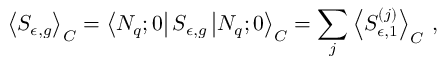Convert formula to latex. <formula><loc_0><loc_0><loc_500><loc_500>\left < S _ { \epsilon , g } \right > _ { C } = \left < N _ { q } ; 0 \right | S _ { \epsilon , g } \left | N _ { q } ; 0 \right > _ { C } = \sum _ { j } \left < S _ { \epsilon , 1 } ^ { ( j ) } \right > _ { C } \, ,</formula> 